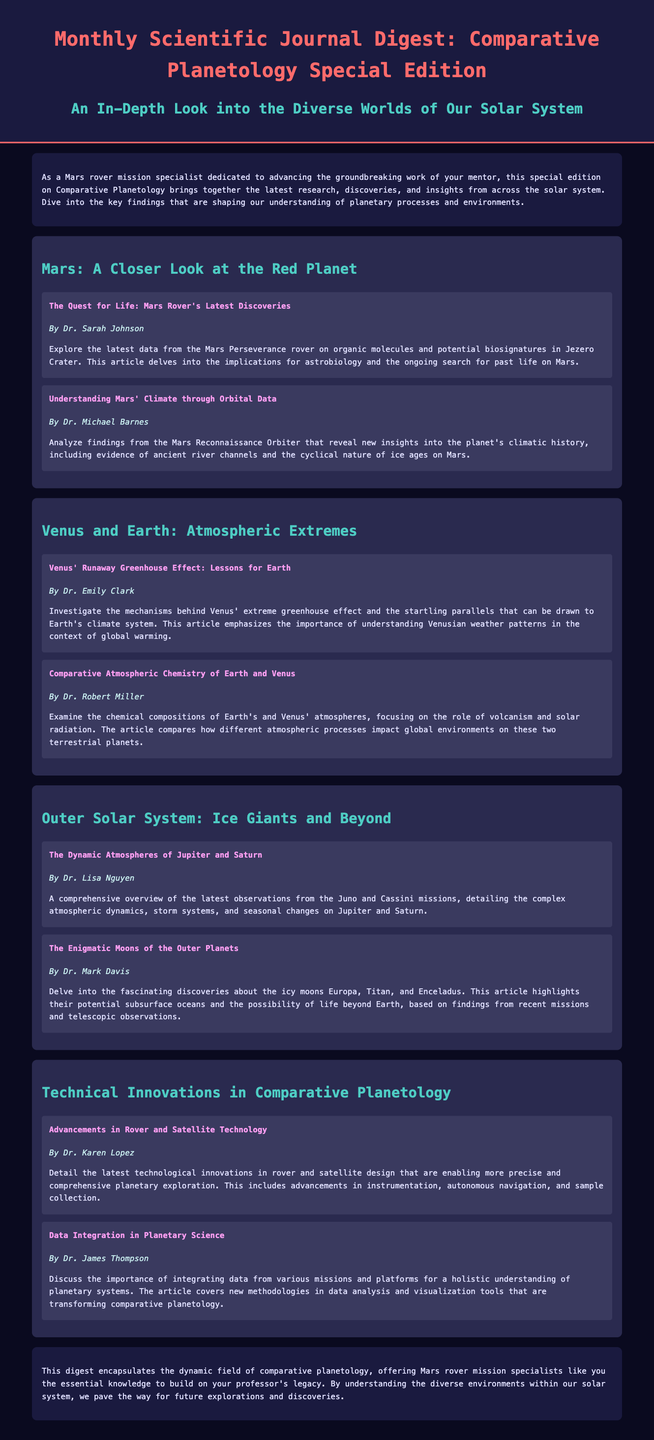What is the title of the journal? The title of the journal is presented prominently at the top of the document, which is "Monthly Scientific Journal Digest: Comparative Planetology Special Edition".
Answer: Monthly Scientific Journal Digest: Comparative Planetology Special Edition Who wrote "The Quest for Life: Mars Rover's Latest Discoveries"? The author of this article is listed directly below the title, which identifies her as Dr. Sarah Johnson.
Answer: Dr. Sarah Johnson How many sections are there in the document? The document includes a structured layout with several sections, specifically four sections covering different planetary topics.
Answer: four What is the main focus of the article by Dr. Emily Clark? The article emphasizes the mechanisms behind Venus' extreme greenhouse effect and how it relates to Earth's climate, as described in the summary of the article.
Answer: Venus' Runaway Greenhouse Effect What do the articles on the outer solar system mainly discuss? The articles in this section analyze discoveries about the giant planets and their moons, particularly from the Juno and Cassini missions, as stated in the article descriptions.
Answer: Jupiter and Saturn's atmospheres What innovations are discussed in the section "Technical Innovations in Comparative Planetology"? This section covers advancements in technology related to planetary exploration and data integration in planetary science according to the titles and summaries provided.
Answer: Rover and satellite technology What does the conclusion highlight for Mars rover mission specialists? The conclusion emphasizes the importance of understanding diverse planetary environments to support future explorations and build on existing knowledge, as articulated in the final paragraph.
Answer: Essential knowledge for future explorations Who is the author of the article "Data Integration in Planetary Science"? This information can be found right before the article's description, indicating Dr. James Thompson is the author.
Answer: Dr. James Thompson 